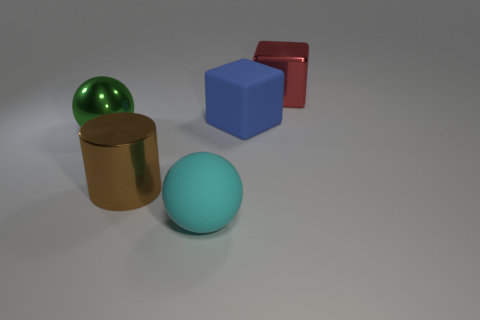Does the image suggest anything about the size of the objects? Without a frame of reference or known objects for scale comparison, it's challenging to ascertain the precise sizes of these objects. However, they are presented with a perspective that suggests they are of a size that could be comfortably placed on a table or in a small room.  Could these objects be part of a game or an educational tool? Certainly, these objects could be part of a manipulative set for educational purposes, teaching concepts such as geometry, volume, and physics. Alternatively, they could be game pieces used for a strategy game focusing on spatial awareness or may even be used in object recognition software development. 